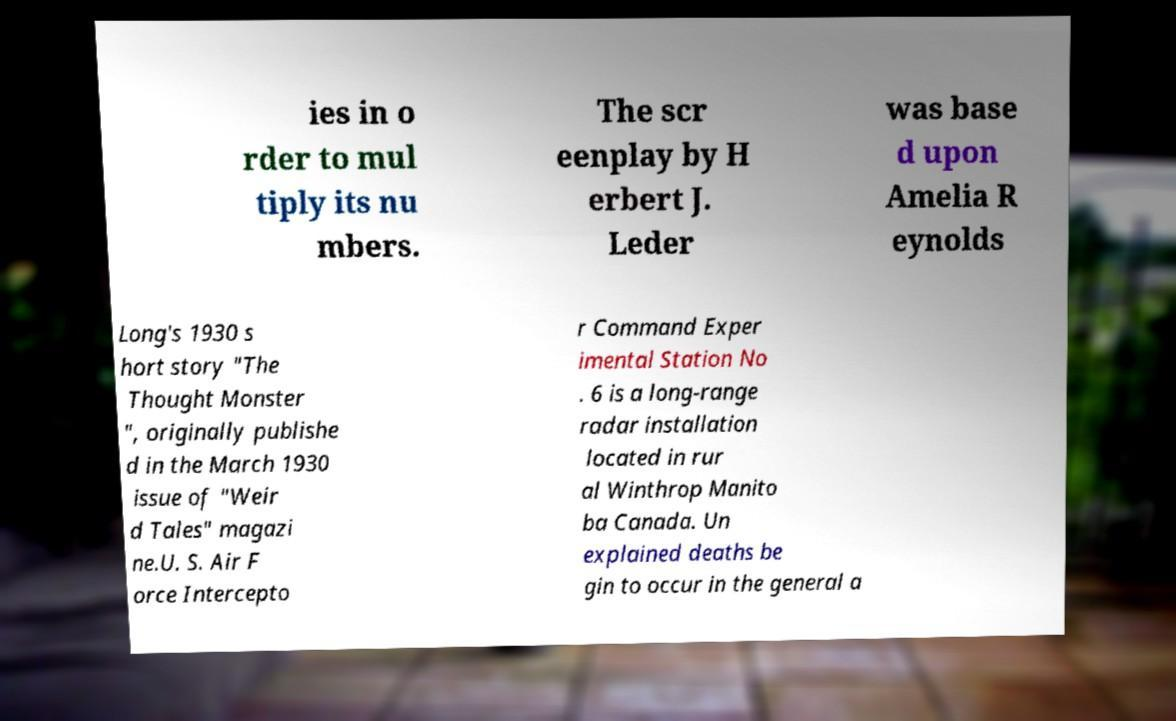Can you read and provide the text displayed in the image?This photo seems to have some interesting text. Can you extract and type it out for me? ies in o rder to mul tiply its nu mbers. The scr eenplay by H erbert J. Leder was base d upon Amelia R eynolds Long's 1930 s hort story "The Thought Monster ", originally publishe d in the March 1930 issue of "Weir d Tales" magazi ne.U. S. Air F orce Intercepto r Command Exper imental Station No . 6 is a long-range radar installation located in rur al Winthrop Manito ba Canada. Un explained deaths be gin to occur in the general a 